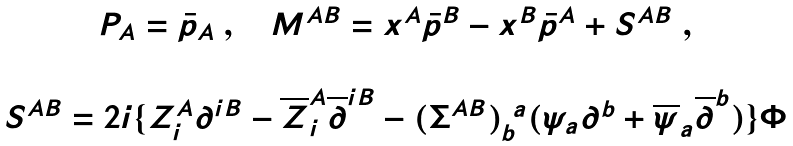<formula> <loc_0><loc_0><loc_500><loc_500>\begin{array} { c } { P } _ { A } = \bar { p } _ { A } \ , \quad M ^ { A B } = x ^ { A } \bar { p } ^ { B } - x ^ { B } \bar { p } ^ { A } + S ^ { A B } \ , \\ \\ S ^ { A B } = 2 i \{ Z _ { i } ^ { A } \partial ^ { i B } - \overline { Z } _ { i } ^ { A } \overline { \partial } ^ { i B } - ( \Sigma ^ { A B } ) _ { b } ^ { \ a } ( \psi _ { a } \partial ^ { b } + \overline { \psi } _ { a } \overline { \partial } ^ { b } ) \} \Phi \end{array}</formula> 